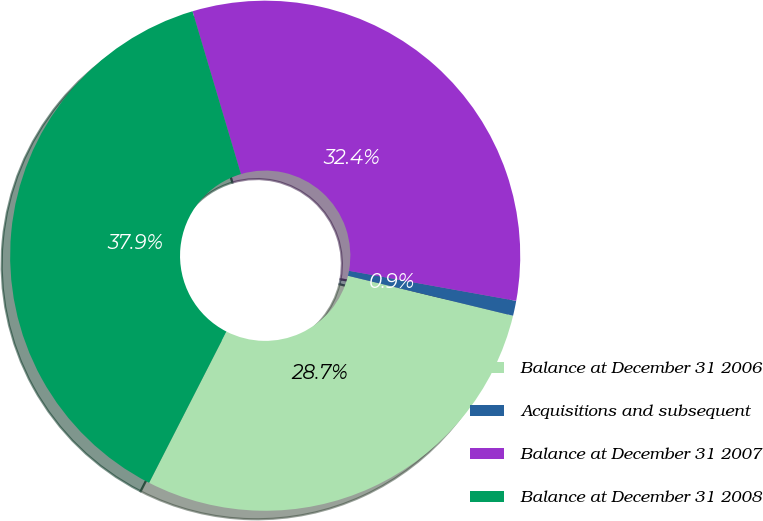<chart> <loc_0><loc_0><loc_500><loc_500><pie_chart><fcel>Balance at December 31 2006<fcel>Acquisitions and subsequent<fcel>Balance at December 31 2007<fcel>Balance at December 31 2008<nl><fcel>28.74%<fcel>0.95%<fcel>32.43%<fcel>37.88%<nl></chart> 